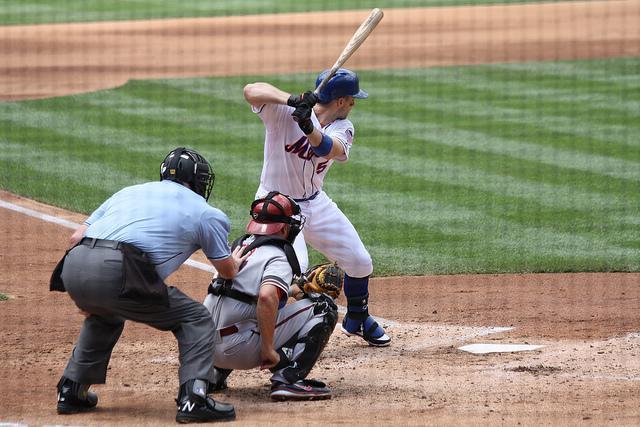How many people are there?
Give a very brief answer. 3. 